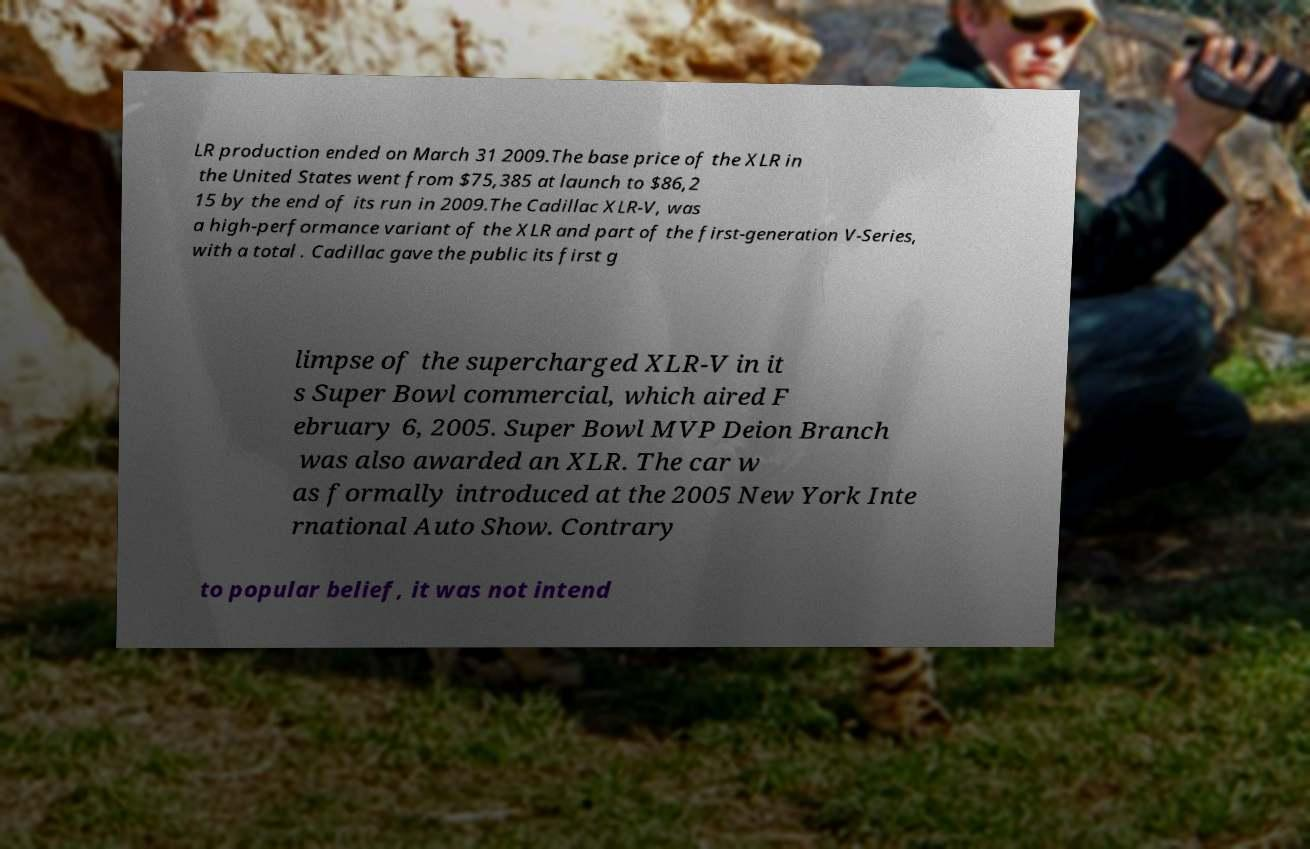Please read and relay the text visible in this image. What does it say? LR production ended on March 31 2009.The base price of the XLR in the United States went from $75,385 at launch to $86,2 15 by the end of its run in 2009.The Cadillac XLR-V, was a high-performance variant of the XLR and part of the first-generation V-Series, with a total . Cadillac gave the public its first g limpse of the supercharged XLR-V in it s Super Bowl commercial, which aired F ebruary 6, 2005. Super Bowl MVP Deion Branch was also awarded an XLR. The car w as formally introduced at the 2005 New York Inte rnational Auto Show. Contrary to popular belief, it was not intend 